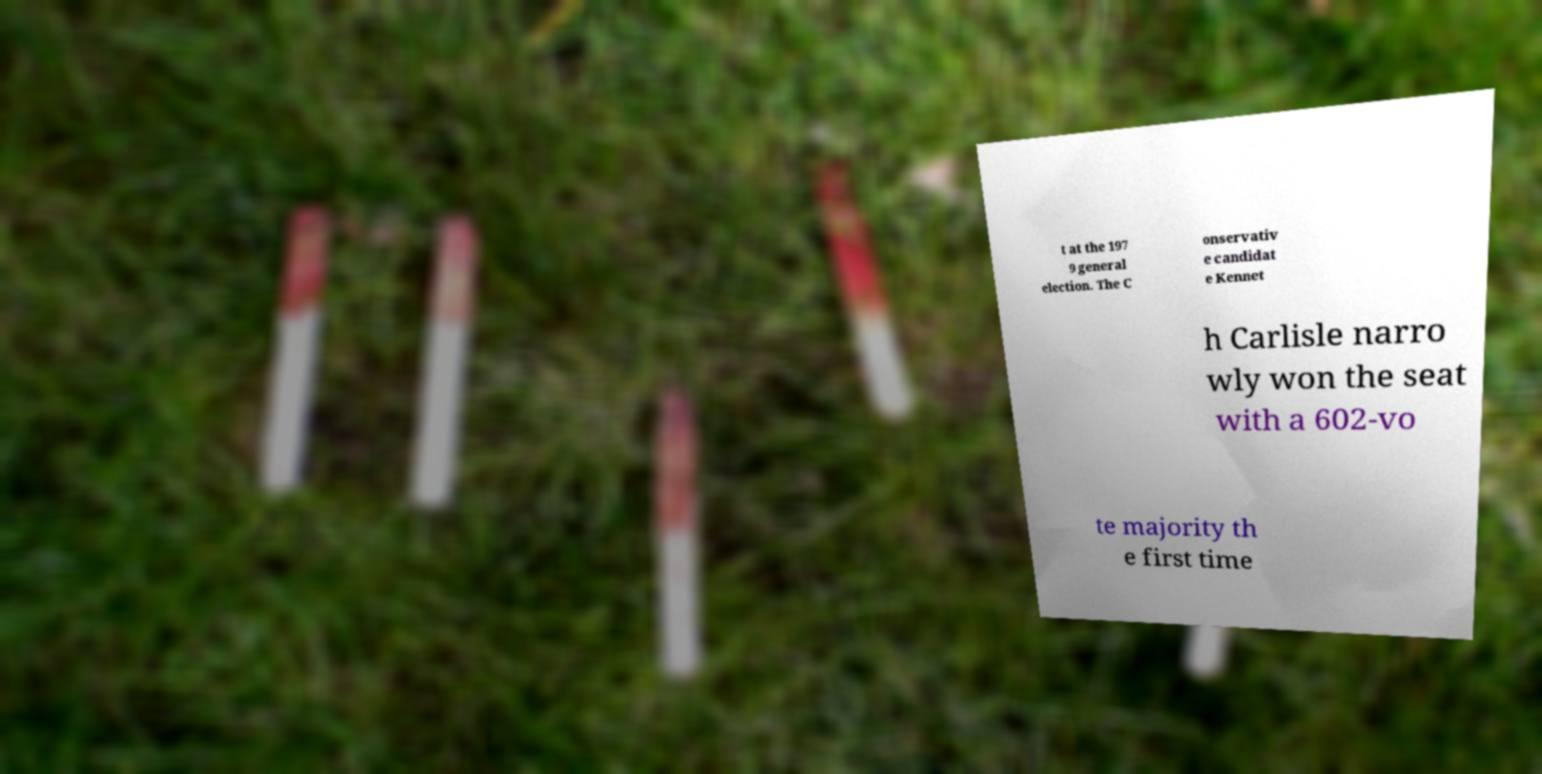Can you read and provide the text displayed in the image?This photo seems to have some interesting text. Can you extract and type it out for me? t at the 197 9 general election. The C onservativ e candidat e Kennet h Carlisle narro wly won the seat with a 602-vo te majority th e first time 